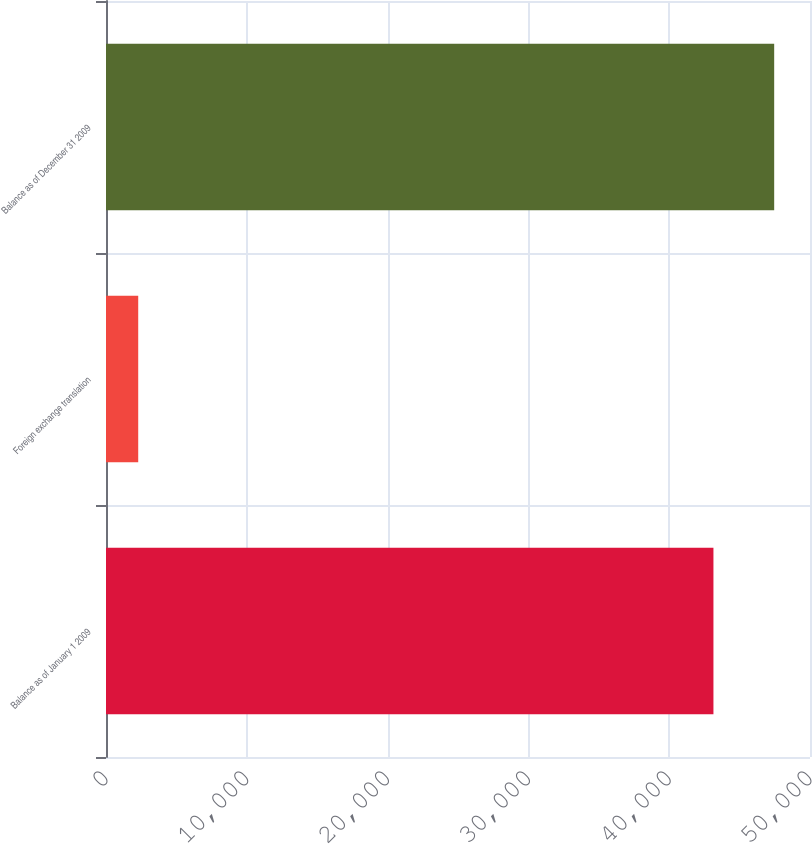<chart> <loc_0><loc_0><loc_500><loc_500><bar_chart><fcel>Balance as of January 1 2009<fcel>Foreign exchange translation<fcel>Balance as of December 31 2009<nl><fcel>43142<fcel>2288<fcel>47456.2<nl></chart> 